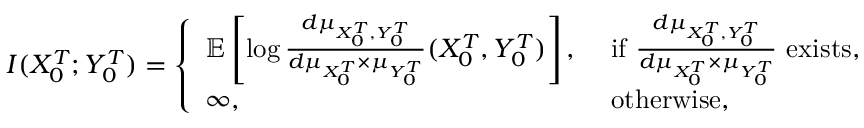<formula> <loc_0><loc_0><loc_500><loc_500>I ( X _ { 0 } ^ { T } ; Y _ { 0 } ^ { T } ) = \left \{ \begin{array} { l l } { { \mathbb { E } } \left [ \log \frac { d \mu _ { X _ { 0 } ^ { T } , Y _ { 0 } ^ { T } } } { d \mu _ { X _ { 0 } ^ { T } } \times \mu _ { Y _ { 0 } ^ { T } } } ( X _ { 0 } ^ { T } , Y _ { 0 } ^ { T } ) \right ] , } & { i f \frac { d \mu _ { X _ { 0 } ^ { T } , { Y _ { 0 } ^ { T } } } } { d \mu _ { X _ { 0 } ^ { T } } \times \mu _ { Y _ { 0 } ^ { T } } } e x i s t s , } \\ { \infty , } & { o t h e r w i s e , } \end{array}</formula> 